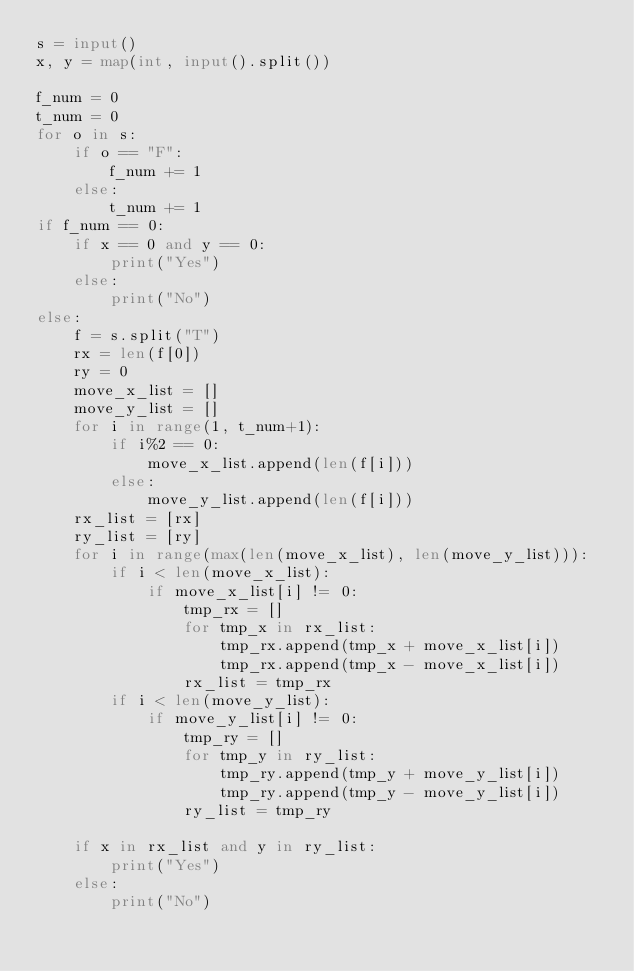Convert code to text. <code><loc_0><loc_0><loc_500><loc_500><_Python_>s = input()
x, y = map(int, input().split())

f_num = 0
t_num = 0
for o in s:
    if o == "F":
        f_num += 1
    else:
        t_num += 1
if f_num == 0:
    if x == 0 and y == 0:
        print("Yes")
    else:
        print("No")
else:
    f = s.split("T")
    rx = len(f[0])
    ry = 0
    move_x_list = []
    move_y_list = []
    for i in range(1, t_num+1):
        if i%2 == 0:
            move_x_list.append(len(f[i]))
        else:
            move_y_list.append(len(f[i]))
    rx_list = [rx]
    ry_list = [ry]
    for i in range(max(len(move_x_list), len(move_y_list))):
        if i < len(move_x_list):
            if move_x_list[i] != 0:
                tmp_rx = []
                for tmp_x in rx_list:
                    tmp_rx.append(tmp_x + move_x_list[i])
                    tmp_rx.append(tmp_x - move_x_list[i])
                rx_list = tmp_rx
        if i < len(move_y_list):
            if move_y_list[i] != 0:
                tmp_ry = []
                for tmp_y in ry_list:
                    tmp_ry.append(tmp_y + move_y_list[i])
                    tmp_ry.append(tmp_y - move_y_list[i])
                ry_list = tmp_ry

    if x in rx_list and y in ry_list:
        print("Yes")
    else:
        print("No")
</code> 